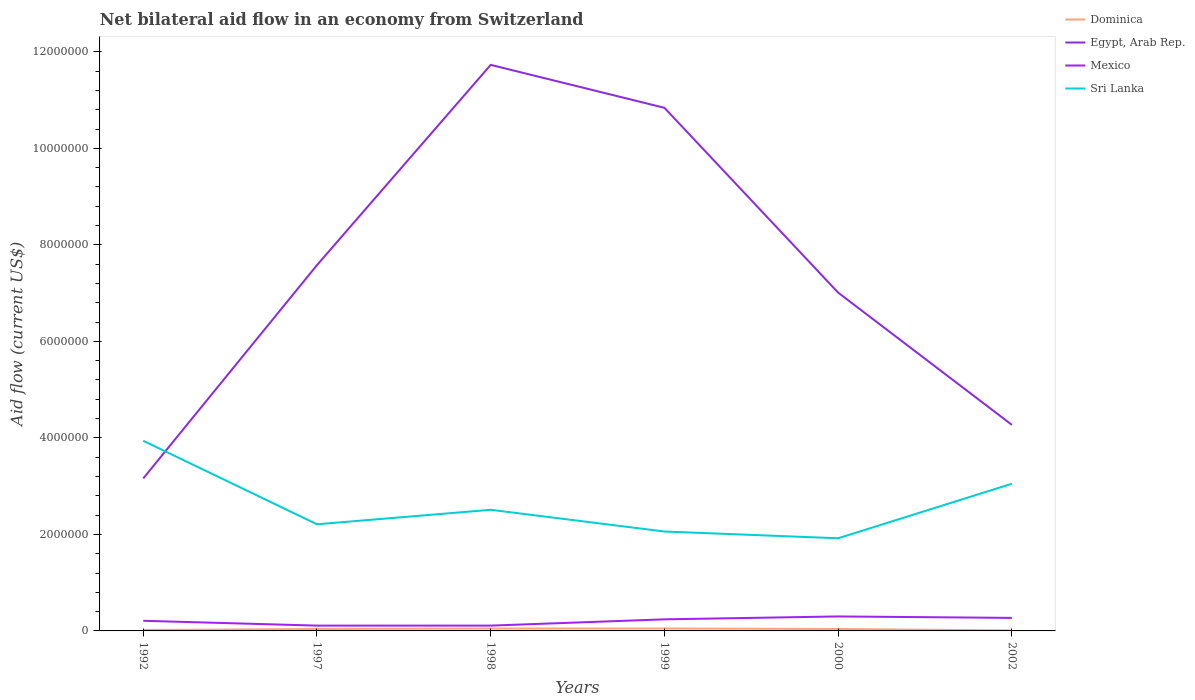How many different coloured lines are there?
Your answer should be compact. 4. Is the number of lines equal to the number of legend labels?
Make the answer very short. Yes. Across all years, what is the maximum net bilateral aid flow in Sri Lanka?
Give a very brief answer. 1.92e+06. In which year was the net bilateral aid flow in Dominica maximum?
Offer a very short reply. 2002. What is the total net bilateral aid flow in Egypt, Arab Rep. in the graph?
Offer a very short reply. 4.72e+06. What is the difference between the highest and the second highest net bilateral aid flow in Egypt, Arab Rep.?
Keep it short and to the point. 8.57e+06. What is the difference between the highest and the lowest net bilateral aid flow in Mexico?
Provide a short and direct response. 4. How many lines are there?
Your response must be concise. 4. What is the difference between two consecutive major ticks on the Y-axis?
Your response must be concise. 2.00e+06. Are the values on the major ticks of Y-axis written in scientific E-notation?
Provide a short and direct response. No. Does the graph contain any zero values?
Offer a terse response. No. Where does the legend appear in the graph?
Give a very brief answer. Top right. How many legend labels are there?
Your answer should be very brief. 4. What is the title of the graph?
Make the answer very short. Net bilateral aid flow in an economy from Switzerland. What is the label or title of the X-axis?
Ensure brevity in your answer.  Years. What is the Aid flow (current US$) of Dominica in 1992?
Your response must be concise. 2.00e+04. What is the Aid flow (current US$) of Egypt, Arab Rep. in 1992?
Make the answer very short. 3.16e+06. What is the Aid flow (current US$) in Sri Lanka in 1992?
Keep it short and to the point. 3.94e+06. What is the Aid flow (current US$) in Egypt, Arab Rep. in 1997?
Offer a terse response. 7.58e+06. What is the Aid flow (current US$) in Mexico in 1997?
Ensure brevity in your answer.  1.10e+05. What is the Aid flow (current US$) in Sri Lanka in 1997?
Your response must be concise. 2.21e+06. What is the Aid flow (current US$) of Egypt, Arab Rep. in 1998?
Offer a terse response. 1.17e+07. What is the Aid flow (current US$) in Mexico in 1998?
Offer a terse response. 1.10e+05. What is the Aid flow (current US$) of Sri Lanka in 1998?
Provide a succinct answer. 2.51e+06. What is the Aid flow (current US$) in Egypt, Arab Rep. in 1999?
Your answer should be very brief. 1.08e+07. What is the Aid flow (current US$) in Sri Lanka in 1999?
Offer a terse response. 2.06e+06. What is the Aid flow (current US$) in Dominica in 2000?
Offer a terse response. 4.00e+04. What is the Aid flow (current US$) in Egypt, Arab Rep. in 2000?
Keep it short and to the point. 7.01e+06. What is the Aid flow (current US$) of Sri Lanka in 2000?
Your answer should be compact. 1.92e+06. What is the Aid flow (current US$) of Dominica in 2002?
Give a very brief answer. 10000. What is the Aid flow (current US$) of Egypt, Arab Rep. in 2002?
Make the answer very short. 4.27e+06. What is the Aid flow (current US$) in Mexico in 2002?
Keep it short and to the point. 2.70e+05. What is the Aid flow (current US$) in Sri Lanka in 2002?
Your response must be concise. 3.05e+06. Across all years, what is the maximum Aid flow (current US$) in Dominica?
Your answer should be very brief. 5.00e+04. Across all years, what is the maximum Aid flow (current US$) of Egypt, Arab Rep.?
Provide a short and direct response. 1.17e+07. Across all years, what is the maximum Aid flow (current US$) of Mexico?
Offer a very short reply. 3.00e+05. Across all years, what is the maximum Aid flow (current US$) of Sri Lanka?
Give a very brief answer. 3.94e+06. Across all years, what is the minimum Aid flow (current US$) of Egypt, Arab Rep.?
Give a very brief answer. 3.16e+06. Across all years, what is the minimum Aid flow (current US$) of Sri Lanka?
Keep it short and to the point. 1.92e+06. What is the total Aid flow (current US$) in Egypt, Arab Rep. in the graph?
Give a very brief answer. 4.46e+07. What is the total Aid flow (current US$) of Mexico in the graph?
Your answer should be compact. 1.24e+06. What is the total Aid flow (current US$) in Sri Lanka in the graph?
Provide a succinct answer. 1.57e+07. What is the difference between the Aid flow (current US$) of Egypt, Arab Rep. in 1992 and that in 1997?
Offer a very short reply. -4.42e+06. What is the difference between the Aid flow (current US$) of Mexico in 1992 and that in 1997?
Your answer should be compact. 1.00e+05. What is the difference between the Aid flow (current US$) in Sri Lanka in 1992 and that in 1997?
Give a very brief answer. 1.73e+06. What is the difference between the Aid flow (current US$) in Egypt, Arab Rep. in 1992 and that in 1998?
Offer a very short reply. -8.57e+06. What is the difference between the Aid flow (current US$) of Sri Lanka in 1992 and that in 1998?
Offer a terse response. 1.43e+06. What is the difference between the Aid flow (current US$) in Dominica in 1992 and that in 1999?
Provide a succinct answer. -3.00e+04. What is the difference between the Aid flow (current US$) in Egypt, Arab Rep. in 1992 and that in 1999?
Provide a succinct answer. -7.68e+06. What is the difference between the Aid flow (current US$) in Mexico in 1992 and that in 1999?
Your response must be concise. -3.00e+04. What is the difference between the Aid flow (current US$) of Sri Lanka in 1992 and that in 1999?
Your answer should be very brief. 1.88e+06. What is the difference between the Aid flow (current US$) in Dominica in 1992 and that in 2000?
Keep it short and to the point. -2.00e+04. What is the difference between the Aid flow (current US$) of Egypt, Arab Rep. in 1992 and that in 2000?
Offer a terse response. -3.85e+06. What is the difference between the Aid flow (current US$) of Sri Lanka in 1992 and that in 2000?
Your response must be concise. 2.02e+06. What is the difference between the Aid flow (current US$) of Dominica in 1992 and that in 2002?
Your response must be concise. 10000. What is the difference between the Aid flow (current US$) of Egypt, Arab Rep. in 1992 and that in 2002?
Make the answer very short. -1.11e+06. What is the difference between the Aid flow (current US$) of Sri Lanka in 1992 and that in 2002?
Keep it short and to the point. 8.90e+05. What is the difference between the Aid flow (current US$) in Egypt, Arab Rep. in 1997 and that in 1998?
Offer a terse response. -4.15e+06. What is the difference between the Aid flow (current US$) in Mexico in 1997 and that in 1998?
Make the answer very short. 0. What is the difference between the Aid flow (current US$) of Sri Lanka in 1997 and that in 1998?
Make the answer very short. -3.00e+05. What is the difference between the Aid flow (current US$) of Egypt, Arab Rep. in 1997 and that in 1999?
Provide a succinct answer. -3.26e+06. What is the difference between the Aid flow (current US$) in Egypt, Arab Rep. in 1997 and that in 2000?
Ensure brevity in your answer.  5.70e+05. What is the difference between the Aid flow (current US$) in Mexico in 1997 and that in 2000?
Provide a succinct answer. -1.90e+05. What is the difference between the Aid flow (current US$) in Dominica in 1997 and that in 2002?
Ensure brevity in your answer.  3.00e+04. What is the difference between the Aid flow (current US$) of Egypt, Arab Rep. in 1997 and that in 2002?
Offer a very short reply. 3.31e+06. What is the difference between the Aid flow (current US$) in Sri Lanka in 1997 and that in 2002?
Offer a very short reply. -8.40e+05. What is the difference between the Aid flow (current US$) in Egypt, Arab Rep. in 1998 and that in 1999?
Offer a very short reply. 8.90e+05. What is the difference between the Aid flow (current US$) in Mexico in 1998 and that in 1999?
Offer a terse response. -1.30e+05. What is the difference between the Aid flow (current US$) in Dominica in 1998 and that in 2000?
Give a very brief answer. 10000. What is the difference between the Aid flow (current US$) of Egypt, Arab Rep. in 1998 and that in 2000?
Make the answer very short. 4.72e+06. What is the difference between the Aid flow (current US$) in Sri Lanka in 1998 and that in 2000?
Make the answer very short. 5.90e+05. What is the difference between the Aid flow (current US$) in Egypt, Arab Rep. in 1998 and that in 2002?
Ensure brevity in your answer.  7.46e+06. What is the difference between the Aid flow (current US$) of Mexico in 1998 and that in 2002?
Your answer should be compact. -1.60e+05. What is the difference between the Aid flow (current US$) of Sri Lanka in 1998 and that in 2002?
Your response must be concise. -5.40e+05. What is the difference between the Aid flow (current US$) in Egypt, Arab Rep. in 1999 and that in 2000?
Make the answer very short. 3.83e+06. What is the difference between the Aid flow (current US$) in Egypt, Arab Rep. in 1999 and that in 2002?
Ensure brevity in your answer.  6.57e+06. What is the difference between the Aid flow (current US$) of Mexico in 1999 and that in 2002?
Give a very brief answer. -3.00e+04. What is the difference between the Aid flow (current US$) of Sri Lanka in 1999 and that in 2002?
Ensure brevity in your answer.  -9.90e+05. What is the difference between the Aid flow (current US$) of Dominica in 2000 and that in 2002?
Ensure brevity in your answer.  3.00e+04. What is the difference between the Aid flow (current US$) of Egypt, Arab Rep. in 2000 and that in 2002?
Make the answer very short. 2.74e+06. What is the difference between the Aid flow (current US$) of Sri Lanka in 2000 and that in 2002?
Offer a terse response. -1.13e+06. What is the difference between the Aid flow (current US$) of Dominica in 1992 and the Aid flow (current US$) of Egypt, Arab Rep. in 1997?
Give a very brief answer. -7.56e+06. What is the difference between the Aid flow (current US$) of Dominica in 1992 and the Aid flow (current US$) of Sri Lanka in 1997?
Provide a short and direct response. -2.19e+06. What is the difference between the Aid flow (current US$) in Egypt, Arab Rep. in 1992 and the Aid flow (current US$) in Mexico in 1997?
Your answer should be very brief. 3.05e+06. What is the difference between the Aid flow (current US$) in Egypt, Arab Rep. in 1992 and the Aid flow (current US$) in Sri Lanka in 1997?
Your answer should be very brief. 9.50e+05. What is the difference between the Aid flow (current US$) of Mexico in 1992 and the Aid flow (current US$) of Sri Lanka in 1997?
Ensure brevity in your answer.  -2.00e+06. What is the difference between the Aid flow (current US$) in Dominica in 1992 and the Aid flow (current US$) in Egypt, Arab Rep. in 1998?
Provide a short and direct response. -1.17e+07. What is the difference between the Aid flow (current US$) in Dominica in 1992 and the Aid flow (current US$) in Sri Lanka in 1998?
Provide a short and direct response. -2.49e+06. What is the difference between the Aid flow (current US$) of Egypt, Arab Rep. in 1992 and the Aid flow (current US$) of Mexico in 1998?
Your answer should be compact. 3.05e+06. What is the difference between the Aid flow (current US$) in Egypt, Arab Rep. in 1992 and the Aid flow (current US$) in Sri Lanka in 1998?
Offer a very short reply. 6.50e+05. What is the difference between the Aid flow (current US$) in Mexico in 1992 and the Aid flow (current US$) in Sri Lanka in 1998?
Your answer should be compact. -2.30e+06. What is the difference between the Aid flow (current US$) in Dominica in 1992 and the Aid flow (current US$) in Egypt, Arab Rep. in 1999?
Offer a very short reply. -1.08e+07. What is the difference between the Aid flow (current US$) in Dominica in 1992 and the Aid flow (current US$) in Sri Lanka in 1999?
Give a very brief answer. -2.04e+06. What is the difference between the Aid flow (current US$) of Egypt, Arab Rep. in 1992 and the Aid flow (current US$) of Mexico in 1999?
Your answer should be very brief. 2.92e+06. What is the difference between the Aid flow (current US$) in Egypt, Arab Rep. in 1992 and the Aid flow (current US$) in Sri Lanka in 1999?
Give a very brief answer. 1.10e+06. What is the difference between the Aid flow (current US$) in Mexico in 1992 and the Aid flow (current US$) in Sri Lanka in 1999?
Your answer should be compact. -1.85e+06. What is the difference between the Aid flow (current US$) in Dominica in 1992 and the Aid flow (current US$) in Egypt, Arab Rep. in 2000?
Make the answer very short. -6.99e+06. What is the difference between the Aid flow (current US$) in Dominica in 1992 and the Aid flow (current US$) in Mexico in 2000?
Offer a very short reply. -2.80e+05. What is the difference between the Aid flow (current US$) of Dominica in 1992 and the Aid flow (current US$) of Sri Lanka in 2000?
Your answer should be very brief. -1.90e+06. What is the difference between the Aid flow (current US$) of Egypt, Arab Rep. in 1992 and the Aid flow (current US$) of Mexico in 2000?
Offer a terse response. 2.86e+06. What is the difference between the Aid flow (current US$) in Egypt, Arab Rep. in 1992 and the Aid flow (current US$) in Sri Lanka in 2000?
Offer a terse response. 1.24e+06. What is the difference between the Aid flow (current US$) of Mexico in 1992 and the Aid flow (current US$) of Sri Lanka in 2000?
Keep it short and to the point. -1.71e+06. What is the difference between the Aid flow (current US$) in Dominica in 1992 and the Aid flow (current US$) in Egypt, Arab Rep. in 2002?
Provide a succinct answer. -4.25e+06. What is the difference between the Aid flow (current US$) of Dominica in 1992 and the Aid flow (current US$) of Mexico in 2002?
Provide a succinct answer. -2.50e+05. What is the difference between the Aid flow (current US$) of Dominica in 1992 and the Aid flow (current US$) of Sri Lanka in 2002?
Ensure brevity in your answer.  -3.03e+06. What is the difference between the Aid flow (current US$) of Egypt, Arab Rep. in 1992 and the Aid flow (current US$) of Mexico in 2002?
Keep it short and to the point. 2.89e+06. What is the difference between the Aid flow (current US$) in Egypt, Arab Rep. in 1992 and the Aid flow (current US$) in Sri Lanka in 2002?
Your response must be concise. 1.10e+05. What is the difference between the Aid flow (current US$) in Mexico in 1992 and the Aid flow (current US$) in Sri Lanka in 2002?
Provide a short and direct response. -2.84e+06. What is the difference between the Aid flow (current US$) of Dominica in 1997 and the Aid flow (current US$) of Egypt, Arab Rep. in 1998?
Your answer should be very brief. -1.17e+07. What is the difference between the Aid flow (current US$) in Dominica in 1997 and the Aid flow (current US$) in Sri Lanka in 1998?
Ensure brevity in your answer.  -2.47e+06. What is the difference between the Aid flow (current US$) in Egypt, Arab Rep. in 1997 and the Aid flow (current US$) in Mexico in 1998?
Offer a very short reply. 7.47e+06. What is the difference between the Aid flow (current US$) of Egypt, Arab Rep. in 1997 and the Aid flow (current US$) of Sri Lanka in 1998?
Your answer should be compact. 5.07e+06. What is the difference between the Aid flow (current US$) in Mexico in 1997 and the Aid flow (current US$) in Sri Lanka in 1998?
Keep it short and to the point. -2.40e+06. What is the difference between the Aid flow (current US$) in Dominica in 1997 and the Aid flow (current US$) in Egypt, Arab Rep. in 1999?
Provide a short and direct response. -1.08e+07. What is the difference between the Aid flow (current US$) in Dominica in 1997 and the Aid flow (current US$) in Sri Lanka in 1999?
Your answer should be compact. -2.02e+06. What is the difference between the Aid flow (current US$) in Egypt, Arab Rep. in 1997 and the Aid flow (current US$) in Mexico in 1999?
Keep it short and to the point. 7.34e+06. What is the difference between the Aid flow (current US$) in Egypt, Arab Rep. in 1997 and the Aid flow (current US$) in Sri Lanka in 1999?
Offer a terse response. 5.52e+06. What is the difference between the Aid flow (current US$) of Mexico in 1997 and the Aid flow (current US$) of Sri Lanka in 1999?
Your answer should be compact. -1.95e+06. What is the difference between the Aid flow (current US$) of Dominica in 1997 and the Aid flow (current US$) of Egypt, Arab Rep. in 2000?
Your answer should be compact. -6.97e+06. What is the difference between the Aid flow (current US$) in Dominica in 1997 and the Aid flow (current US$) in Mexico in 2000?
Ensure brevity in your answer.  -2.60e+05. What is the difference between the Aid flow (current US$) of Dominica in 1997 and the Aid flow (current US$) of Sri Lanka in 2000?
Provide a succinct answer. -1.88e+06. What is the difference between the Aid flow (current US$) in Egypt, Arab Rep. in 1997 and the Aid flow (current US$) in Mexico in 2000?
Provide a short and direct response. 7.28e+06. What is the difference between the Aid flow (current US$) in Egypt, Arab Rep. in 1997 and the Aid flow (current US$) in Sri Lanka in 2000?
Your answer should be very brief. 5.66e+06. What is the difference between the Aid flow (current US$) of Mexico in 1997 and the Aid flow (current US$) of Sri Lanka in 2000?
Ensure brevity in your answer.  -1.81e+06. What is the difference between the Aid flow (current US$) in Dominica in 1997 and the Aid flow (current US$) in Egypt, Arab Rep. in 2002?
Your answer should be very brief. -4.23e+06. What is the difference between the Aid flow (current US$) in Dominica in 1997 and the Aid flow (current US$) in Sri Lanka in 2002?
Provide a succinct answer. -3.01e+06. What is the difference between the Aid flow (current US$) in Egypt, Arab Rep. in 1997 and the Aid flow (current US$) in Mexico in 2002?
Your answer should be very brief. 7.31e+06. What is the difference between the Aid flow (current US$) in Egypt, Arab Rep. in 1997 and the Aid flow (current US$) in Sri Lanka in 2002?
Your answer should be compact. 4.53e+06. What is the difference between the Aid flow (current US$) in Mexico in 1997 and the Aid flow (current US$) in Sri Lanka in 2002?
Keep it short and to the point. -2.94e+06. What is the difference between the Aid flow (current US$) in Dominica in 1998 and the Aid flow (current US$) in Egypt, Arab Rep. in 1999?
Provide a succinct answer. -1.08e+07. What is the difference between the Aid flow (current US$) of Dominica in 1998 and the Aid flow (current US$) of Sri Lanka in 1999?
Offer a very short reply. -2.01e+06. What is the difference between the Aid flow (current US$) of Egypt, Arab Rep. in 1998 and the Aid flow (current US$) of Mexico in 1999?
Offer a very short reply. 1.15e+07. What is the difference between the Aid flow (current US$) in Egypt, Arab Rep. in 1998 and the Aid flow (current US$) in Sri Lanka in 1999?
Provide a short and direct response. 9.67e+06. What is the difference between the Aid flow (current US$) of Mexico in 1998 and the Aid flow (current US$) of Sri Lanka in 1999?
Ensure brevity in your answer.  -1.95e+06. What is the difference between the Aid flow (current US$) of Dominica in 1998 and the Aid flow (current US$) of Egypt, Arab Rep. in 2000?
Make the answer very short. -6.96e+06. What is the difference between the Aid flow (current US$) of Dominica in 1998 and the Aid flow (current US$) of Mexico in 2000?
Provide a short and direct response. -2.50e+05. What is the difference between the Aid flow (current US$) of Dominica in 1998 and the Aid flow (current US$) of Sri Lanka in 2000?
Provide a succinct answer. -1.87e+06. What is the difference between the Aid flow (current US$) of Egypt, Arab Rep. in 1998 and the Aid flow (current US$) of Mexico in 2000?
Ensure brevity in your answer.  1.14e+07. What is the difference between the Aid flow (current US$) of Egypt, Arab Rep. in 1998 and the Aid flow (current US$) of Sri Lanka in 2000?
Offer a terse response. 9.81e+06. What is the difference between the Aid flow (current US$) in Mexico in 1998 and the Aid flow (current US$) in Sri Lanka in 2000?
Keep it short and to the point. -1.81e+06. What is the difference between the Aid flow (current US$) in Dominica in 1998 and the Aid flow (current US$) in Egypt, Arab Rep. in 2002?
Your answer should be very brief. -4.22e+06. What is the difference between the Aid flow (current US$) of Egypt, Arab Rep. in 1998 and the Aid flow (current US$) of Mexico in 2002?
Keep it short and to the point. 1.15e+07. What is the difference between the Aid flow (current US$) of Egypt, Arab Rep. in 1998 and the Aid flow (current US$) of Sri Lanka in 2002?
Offer a terse response. 8.68e+06. What is the difference between the Aid flow (current US$) of Mexico in 1998 and the Aid flow (current US$) of Sri Lanka in 2002?
Your answer should be very brief. -2.94e+06. What is the difference between the Aid flow (current US$) of Dominica in 1999 and the Aid flow (current US$) of Egypt, Arab Rep. in 2000?
Provide a short and direct response. -6.96e+06. What is the difference between the Aid flow (current US$) of Dominica in 1999 and the Aid flow (current US$) of Mexico in 2000?
Give a very brief answer. -2.50e+05. What is the difference between the Aid flow (current US$) of Dominica in 1999 and the Aid flow (current US$) of Sri Lanka in 2000?
Your answer should be compact. -1.87e+06. What is the difference between the Aid flow (current US$) in Egypt, Arab Rep. in 1999 and the Aid flow (current US$) in Mexico in 2000?
Offer a terse response. 1.05e+07. What is the difference between the Aid flow (current US$) of Egypt, Arab Rep. in 1999 and the Aid flow (current US$) of Sri Lanka in 2000?
Provide a short and direct response. 8.92e+06. What is the difference between the Aid flow (current US$) in Mexico in 1999 and the Aid flow (current US$) in Sri Lanka in 2000?
Your answer should be very brief. -1.68e+06. What is the difference between the Aid flow (current US$) of Dominica in 1999 and the Aid flow (current US$) of Egypt, Arab Rep. in 2002?
Your answer should be very brief. -4.22e+06. What is the difference between the Aid flow (current US$) of Dominica in 1999 and the Aid flow (current US$) of Sri Lanka in 2002?
Your answer should be very brief. -3.00e+06. What is the difference between the Aid flow (current US$) in Egypt, Arab Rep. in 1999 and the Aid flow (current US$) in Mexico in 2002?
Keep it short and to the point. 1.06e+07. What is the difference between the Aid flow (current US$) in Egypt, Arab Rep. in 1999 and the Aid flow (current US$) in Sri Lanka in 2002?
Ensure brevity in your answer.  7.79e+06. What is the difference between the Aid flow (current US$) in Mexico in 1999 and the Aid flow (current US$) in Sri Lanka in 2002?
Make the answer very short. -2.81e+06. What is the difference between the Aid flow (current US$) in Dominica in 2000 and the Aid flow (current US$) in Egypt, Arab Rep. in 2002?
Provide a short and direct response. -4.23e+06. What is the difference between the Aid flow (current US$) of Dominica in 2000 and the Aid flow (current US$) of Sri Lanka in 2002?
Your answer should be very brief. -3.01e+06. What is the difference between the Aid flow (current US$) of Egypt, Arab Rep. in 2000 and the Aid flow (current US$) of Mexico in 2002?
Offer a terse response. 6.74e+06. What is the difference between the Aid flow (current US$) in Egypt, Arab Rep. in 2000 and the Aid flow (current US$) in Sri Lanka in 2002?
Your response must be concise. 3.96e+06. What is the difference between the Aid flow (current US$) in Mexico in 2000 and the Aid flow (current US$) in Sri Lanka in 2002?
Your answer should be compact. -2.75e+06. What is the average Aid flow (current US$) in Dominica per year?
Keep it short and to the point. 3.50e+04. What is the average Aid flow (current US$) in Egypt, Arab Rep. per year?
Offer a terse response. 7.43e+06. What is the average Aid flow (current US$) of Mexico per year?
Offer a very short reply. 2.07e+05. What is the average Aid flow (current US$) in Sri Lanka per year?
Make the answer very short. 2.62e+06. In the year 1992, what is the difference between the Aid flow (current US$) in Dominica and Aid flow (current US$) in Egypt, Arab Rep.?
Make the answer very short. -3.14e+06. In the year 1992, what is the difference between the Aid flow (current US$) in Dominica and Aid flow (current US$) in Sri Lanka?
Your answer should be very brief. -3.92e+06. In the year 1992, what is the difference between the Aid flow (current US$) in Egypt, Arab Rep. and Aid flow (current US$) in Mexico?
Provide a succinct answer. 2.95e+06. In the year 1992, what is the difference between the Aid flow (current US$) in Egypt, Arab Rep. and Aid flow (current US$) in Sri Lanka?
Your answer should be very brief. -7.80e+05. In the year 1992, what is the difference between the Aid flow (current US$) of Mexico and Aid flow (current US$) of Sri Lanka?
Offer a very short reply. -3.73e+06. In the year 1997, what is the difference between the Aid flow (current US$) of Dominica and Aid flow (current US$) of Egypt, Arab Rep.?
Make the answer very short. -7.54e+06. In the year 1997, what is the difference between the Aid flow (current US$) of Dominica and Aid flow (current US$) of Sri Lanka?
Give a very brief answer. -2.17e+06. In the year 1997, what is the difference between the Aid flow (current US$) of Egypt, Arab Rep. and Aid flow (current US$) of Mexico?
Offer a terse response. 7.47e+06. In the year 1997, what is the difference between the Aid flow (current US$) of Egypt, Arab Rep. and Aid flow (current US$) of Sri Lanka?
Offer a terse response. 5.37e+06. In the year 1997, what is the difference between the Aid flow (current US$) of Mexico and Aid flow (current US$) of Sri Lanka?
Give a very brief answer. -2.10e+06. In the year 1998, what is the difference between the Aid flow (current US$) in Dominica and Aid flow (current US$) in Egypt, Arab Rep.?
Make the answer very short. -1.17e+07. In the year 1998, what is the difference between the Aid flow (current US$) of Dominica and Aid flow (current US$) of Mexico?
Offer a very short reply. -6.00e+04. In the year 1998, what is the difference between the Aid flow (current US$) in Dominica and Aid flow (current US$) in Sri Lanka?
Provide a short and direct response. -2.46e+06. In the year 1998, what is the difference between the Aid flow (current US$) of Egypt, Arab Rep. and Aid flow (current US$) of Mexico?
Your answer should be very brief. 1.16e+07. In the year 1998, what is the difference between the Aid flow (current US$) in Egypt, Arab Rep. and Aid flow (current US$) in Sri Lanka?
Make the answer very short. 9.22e+06. In the year 1998, what is the difference between the Aid flow (current US$) of Mexico and Aid flow (current US$) of Sri Lanka?
Offer a very short reply. -2.40e+06. In the year 1999, what is the difference between the Aid flow (current US$) of Dominica and Aid flow (current US$) of Egypt, Arab Rep.?
Offer a terse response. -1.08e+07. In the year 1999, what is the difference between the Aid flow (current US$) in Dominica and Aid flow (current US$) in Mexico?
Keep it short and to the point. -1.90e+05. In the year 1999, what is the difference between the Aid flow (current US$) of Dominica and Aid flow (current US$) of Sri Lanka?
Ensure brevity in your answer.  -2.01e+06. In the year 1999, what is the difference between the Aid flow (current US$) in Egypt, Arab Rep. and Aid flow (current US$) in Mexico?
Offer a terse response. 1.06e+07. In the year 1999, what is the difference between the Aid flow (current US$) in Egypt, Arab Rep. and Aid flow (current US$) in Sri Lanka?
Your response must be concise. 8.78e+06. In the year 1999, what is the difference between the Aid flow (current US$) of Mexico and Aid flow (current US$) of Sri Lanka?
Provide a short and direct response. -1.82e+06. In the year 2000, what is the difference between the Aid flow (current US$) in Dominica and Aid flow (current US$) in Egypt, Arab Rep.?
Provide a succinct answer. -6.97e+06. In the year 2000, what is the difference between the Aid flow (current US$) in Dominica and Aid flow (current US$) in Mexico?
Your response must be concise. -2.60e+05. In the year 2000, what is the difference between the Aid flow (current US$) of Dominica and Aid flow (current US$) of Sri Lanka?
Keep it short and to the point. -1.88e+06. In the year 2000, what is the difference between the Aid flow (current US$) of Egypt, Arab Rep. and Aid flow (current US$) of Mexico?
Your answer should be very brief. 6.71e+06. In the year 2000, what is the difference between the Aid flow (current US$) in Egypt, Arab Rep. and Aid flow (current US$) in Sri Lanka?
Give a very brief answer. 5.09e+06. In the year 2000, what is the difference between the Aid flow (current US$) of Mexico and Aid flow (current US$) of Sri Lanka?
Make the answer very short. -1.62e+06. In the year 2002, what is the difference between the Aid flow (current US$) of Dominica and Aid flow (current US$) of Egypt, Arab Rep.?
Keep it short and to the point. -4.26e+06. In the year 2002, what is the difference between the Aid flow (current US$) in Dominica and Aid flow (current US$) in Mexico?
Make the answer very short. -2.60e+05. In the year 2002, what is the difference between the Aid flow (current US$) of Dominica and Aid flow (current US$) of Sri Lanka?
Offer a very short reply. -3.04e+06. In the year 2002, what is the difference between the Aid flow (current US$) in Egypt, Arab Rep. and Aid flow (current US$) in Mexico?
Provide a short and direct response. 4.00e+06. In the year 2002, what is the difference between the Aid flow (current US$) in Egypt, Arab Rep. and Aid flow (current US$) in Sri Lanka?
Offer a terse response. 1.22e+06. In the year 2002, what is the difference between the Aid flow (current US$) of Mexico and Aid flow (current US$) of Sri Lanka?
Give a very brief answer. -2.78e+06. What is the ratio of the Aid flow (current US$) in Dominica in 1992 to that in 1997?
Your answer should be compact. 0.5. What is the ratio of the Aid flow (current US$) in Egypt, Arab Rep. in 1992 to that in 1997?
Give a very brief answer. 0.42. What is the ratio of the Aid flow (current US$) in Mexico in 1992 to that in 1997?
Offer a very short reply. 1.91. What is the ratio of the Aid flow (current US$) in Sri Lanka in 1992 to that in 1997?
Make the answer very short. 1.78. What is the ratio of the Aid flow (current US$) of Egypt, Arab Rep. in 1992 to that in 1998?
Provide a short and direct response. 0.27. What is the ratio of the Aid flow (current US$) of Mexico in 1992 to that in 1998?
Keep it short and to the point. 1.91. What is the ratio of the Aid flow (current US$) of Sri Lanka in 1992 to that in 1998?
Give a very brief answer. 1.57. What is the ratio of the Aid flow (current US$) of Dominica in 1992 to that in 1999?
Give a very brief answer. 0.4. What is the ratio of the Aid flow (current US$) in Egypt, Arab Rep. in 1992 to that in 1999?
Offer a terse response. 0.29. What is the ratio of the Aid flow (current US$) of Mexico in 1992 to that in 1999?
Offer a very short reply. 0.88. What is the ratio of the Aid flow (current US$) in Sri Lanka in 1992 to that in 1999?
Offer a terse response. 1.91. What is the ratio of the Aid flow (current US$) in Egypt, Arab Rep. in 1992 to that in 2000?
Your answer should be compact. 0.45. What is the ratio of the Aid flow (current US$) in Mexico in 1992 to that in 2000?
Give a very brief answer. 0.7. What is the ratio of the Aid flow (current US$) of Sri Lanka in 1992 to that in 2000?
Keep it short and to the point. 2.05. What is the ratio of the Aid flow (current US$) of Dominica in 1992 to that in 2002?
Ensure brevity in your answer.  2. What is the ratio of the Aid flow (current US$) of Egypt, Arab Rep. in 1992 to that in 2002?
Keep it short and to the point. 0.74. What is the ratio of the Aid flow (current US$) in Sri Lanka in 1992 to that in 2002?
Your answer should be compact. 1.29. What is the ratio of the Aid flow (current US$) in Dominica in 1997 to that in 1998?
Make the answer very short. 0.8. What is the ratio of the Aid flow (current US$) in Egypt, Arab Rep. in 1997 to that in 1998?
Your answer should be very brief. 0.65. What is the ratio of the Aid flow (current US$) in Mexico in 1997 to that in 1998?
Your answer should be very brief. 1. What is the ratio of the Aid flow (current US$) of Sri Lanka in 1997 to that in 1998?
Make the answer very short. 0.88. What is the ratio of the Aid flow (current US$) in Egypt, Arab Rep. in 1997 to that in 1999?
Your answer should be compact. 0.7. What is the ratio of the Aid flow (current US$) of Mexico in 1997 to that in 1999?
Make the answer very short. 0.46. What is the ratio of the Aid flow (current US$) of Sri Lanka in 1997 to that in 1999?
Offer a very short reply. 1.07. What is the ratio of the Aid flow (current US$) in Dominica in 1997 to that in 2000?
Provide a short and direct response. 1. What is the ratio of the Aid flow (current US$) of Egypt, Arab Rep. in 1997 to that in 2000?
Your answer should be very brief. 1.08. What is the ratio of the Aid flow (current US$) of Mexico in 1997 to that in 2000?
Offer a terse response. 0.37. What is the ratio of the Aid flow (current US$) of Sri Lanka in 1997 to that in 2000?
Ensure brevity in your answer.  1.15. What is the ratio of the Aid flow (current US$) in Dominica in 1997 to that in 2002?
Provide a short and direct response. 4. What is the ratio of the Aid flow (current US$) in Egypt, Arab Rep. in 1997 to that in 2002?
Provide a short and direct response. 1.78. What is the ratio of the Aid flow (current US$) of Mexico in 1997 to that in 2002?
Offer a terse response. 0.41. What is the ratio of the Aid flow (current US$) in Sri Lanka in 1997 to that in 2002?
Provide a short and direct response. 0.72. What is the ratio of the Aid flow (current US$) in Dominica in 1998 to that in 1999?
Provide a succinct answer. 1. What is the ratio of the Aid flow (current US$) in Egypt, Arab Rep. in 1998 to that in 1999?
Your answer should be very brief. 1.08. What is the ratio of the Aid flow (current US$) in Mexico in 1998 to that in 1999?
Ensure brevity in your answer.  0.46. What is the ratio of the Aid flow (current US$) in Sri Lanka in 1998 to that in 1999?
Your answer should be very brief. 1.22. What is the ratio of the Aid flow (current US$) in Egypt, Arab Rep. in 1998 to that in 2000?
Your answer should be very brief. 1.67. What is the ratio of the Aid flow (current US$) in Mexico in 1998 to that in 2000?
Offer a very short reply. 0.37. What is the ratio of the Aid flow (current US$) in Sri Lanka in 1998 to that in 2000?
Offer a terse response. 1.31. What is the ratio of the Aid flow (current US$) in Dominica in 1998 to that in 2002?
Offer a very short reply. 5. What is the ratio of the Aid flow (current US$) in Egypt, Arab Rep. in 1998 to that in 2002?
Ensure brevity in your answer.  2.75. What is the ratio of the Aid flow (current US$) in Mexico in 1998 to that in 2002?
Provide a short and direct response. 0.41. What is the ratio of the Aid flow (current US$) in Sri Lanka in 1998 to that in 2002?
Give a very brief answer. 0.82. What is the ratio of the Aid flow (current US$) of Egypt, Arab Rep. in 1999 to that in 2000?
Ensure brevity in your answer.  1.55. What is the ratio of the Aid flow (current US$) of Sri Lanka in 1999 to that in 2000?
Your answer should be compact. 1.07. What is the ratio of the Aid flow (current US$) in Egypt, Arab Rep. in 1999 to that in 2002?
Make the answer very short. 2.54. What is the ratio of the Aid flow (current US$) of Mexico in 1999 to that in 2002?
Your response must be concise. 0.89. What is the ratio of the Aid flow (current US$) in Sri Lanka in 1999 to that in 2002?
Offer a very short reply. 0.68. What is the ratio of the Aid flow (current US$) of Dominica in 2000 to that in 2002?
Offer a terse response. 4. What is the ratio of the Aid flow (current US$) of Egypt, Arab Rep. in 2000 to that in 2002?
Offer a terse response. 1.64. What is the ratio of the Aid flow (current US$) of Mexico in 2000 to that in 2002?
Your response must be concise. 1.11. What is the ratio of the Aid flow (current US$) of Sri Lanka in 2000 to that in 2002?
Ensure brevity in your answer.  0.63. What is the difference between the highest and the second highest Aid flow (current US$) of Dominica?
Keep it short and to the point. 0. What is the difference between the highest and the second highest Aid flow (current US$) in Egypt, Arab Rep.?
Provide a succinct answer. 8.90e+05. What is the difference between the highest and the second highest Aid flow (current US$) of Sri Lanka?
Offer a terse response. 8.90e+05. What is the difference between the highest and the lowest Aid flow (current US$) in Dominica?
Your answer should be very brief. 4.00e+04. What is the difference between the highest and the lowest Aid flow (current US$) of Egypt, Arab Rep.?
Give a very brief answer. 8.57e+06. What is the difference between the highest and the lowest Aid flow (current US$) of Mexico?
Your response must be concise. 1.90e+05. What is the difference between the highest and the lowest Aid flow (current US$) in Sri Lanka?
Give a very brief answer. 2.02e+06. 